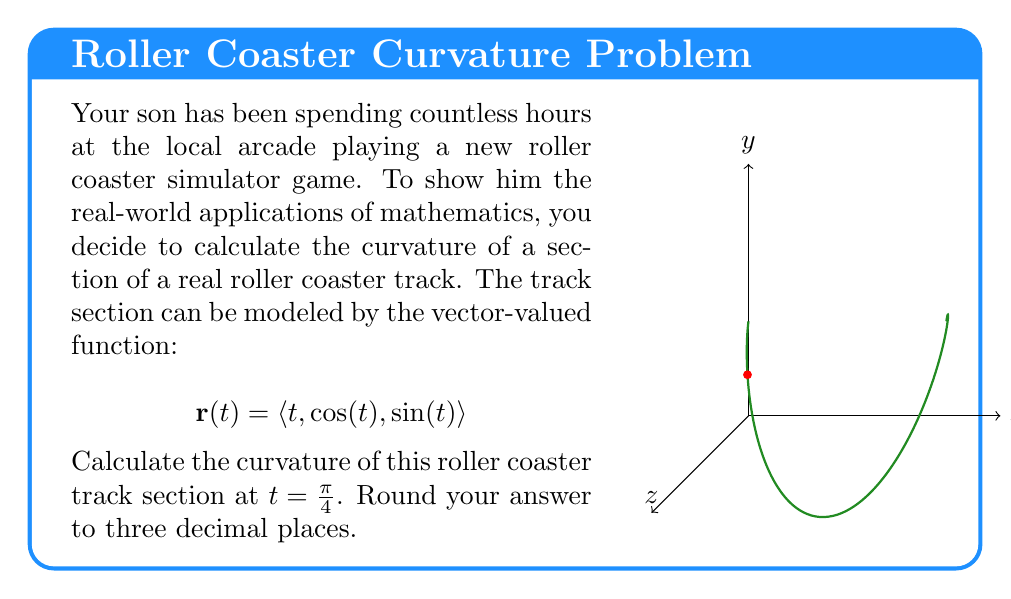Teach me how to tackle this problem. Let's approach this step-by-step:

1) The curvature formula for a vector-valued function is:

   $$\kappa = \frac{|\mathbf{r}'(t) \times \mathbf{r}''(t)|}{|\mathbf{r}'(t)|^3}$$

2) First, we need to find $\mathbf{r}'(t)$ and $\mathbf{r}''(t)$:
   
   $$\mathbf{r}'(t) = \langle 1, -\sin(t), \cos(t) \rangle$$
   $$\mathbf{r}''(t) = \langle 0, -\cos(t), -\sin(t) \rangle$$

3) Now, let's calculate $\mathbf{r}'(t) \times \mathbf{r}''(t)$:
   
   $$\mathbf{r}'(t) \times \mathbf{r}''(t) = \begin{vmatrix} 
   \mathbf{i} & \mathbf{j} & \mathbf{k} \\
   1 & -\sin(t) & \cos(t) \\
   0 & -\cos(t) & -\sin(t)
   \end{vmatrix}$$
   
   $$= \langle \sin^2(t) + \cos^2(t), -\sin(t), -\cos(t) \rangle$$
   $$= \langle 1, -\sin(t), -\cos(t) \rangle$$

4) The magnitude of this cross product is:
   
   $$|\mathbf{r}'(t) \times \mathbf{r}''(t)| = \sqrt{1^2 + \sin^2(t) + \cos^2(t)} = \sqrt{2}$$

5) Next, we need $|\mathbf{r}'(t)|^3$:
   
   $$|\mathbf{r}'(t)| = \sqrt{1^2 + \sin^2(t) + \cos^2(t)} = \sqrt{2}$$
   $$|\mathbf{r}'(t)|^3 = (\sqrt{2})^3 = 2\sqrt{2}$$

6) Now we can calculate the curvature:

   $$\kappa = \frac{\sqrt{2}}{2\sqrt{2}} = \frac{1}{2} = 0.5$$

7) The question asks for the curvature at $t = \frac{\pi}{4}$, but as we can see, the curvature is constant and doesn't depend on $t$.

8) Rounding to three decimal places: 0.500
Answer: 0.500 